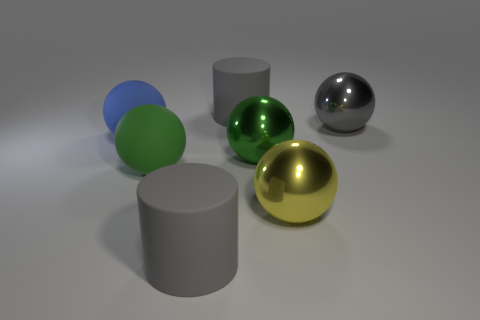Subtract all yellow spheres. How many spheres are left? 4 Subtract all brown blocks. How many green spheres are left? 2 Subtract all green rubber balls. How many balls are left? 4 Add 1 yellow objects. How many objects exist? 8 Subtract all yellow balls. Subtract all brown cubes. How many balls are left? 4 Subtract all cylinders. How many objects are left? 5 Subtract all big objects. Subtract all small blue matte cylinders. How many objects are left? 0 Add 4 large green spheres. How many large green spheres are left? 6 Add 4 yellow shiny spheres. How many yellow shiny spheres exist? 5 Subtract 0 purple cylinders. How many objects are left? 7 